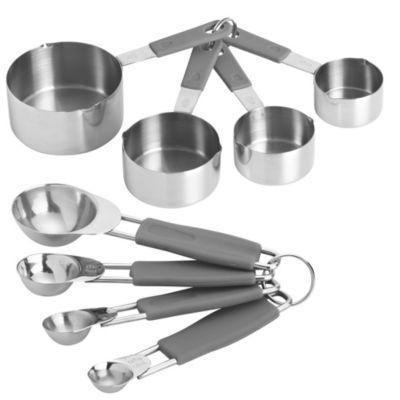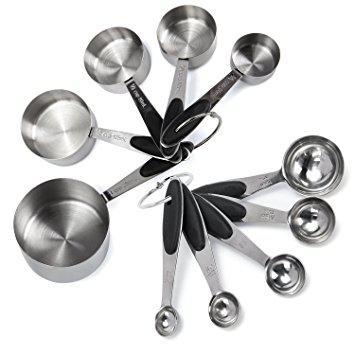The first image is the image on the left, the second image is the image on the right. Examine the images to the left and right. Is the description "The right image shows only one set of measuring utensils joined together." accurate? Answer yes or no. No. 